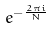<formula> <loc_0><loc_0><loc_500><loc_500>e ^ { - \frac { 2 \pi i } { N } }</formula> 